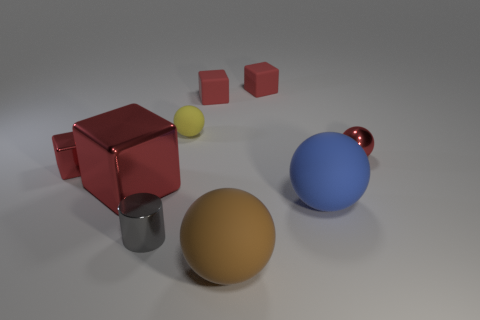There is a tiny metal sphere; is it the same color as the small metal thing that is to the left of the big metal cube?
Offer a terse response. Yes. What number of small matte objects are the same shape as the large red object?
Keep it short and to the point. 2. There is a tiny red block in front of the red sphere; what is it made of?
Give a very brief answer. Metal. Is the shape of the large blue matte thing that is to the right of the big brown sphere the same as  the large brown matte object?
Provide a short and direct response. Yes. Are there any gray metallic things that have the same size as the yellow matte ball?
Your answer should be very brief. Yes. Does the gray object have the same shape as the tiny red metallic object that is behind the small red metal block?
Your response must be concise. No. What is the shape of the small metallic thing that is the same color as the metallic ball?
Provide a short and direct response. Cube. Are there fewer tiny gray things behind the big red metal thing than shiny cubes?
Offer a terse response. Yes. Do the gray thing and the large blue rubber thing have the same shape?
Offer a very short reply. No. There is a red sphere that is the same material as the cylinder; what is its size?
Provide a short and direct response. Small. 